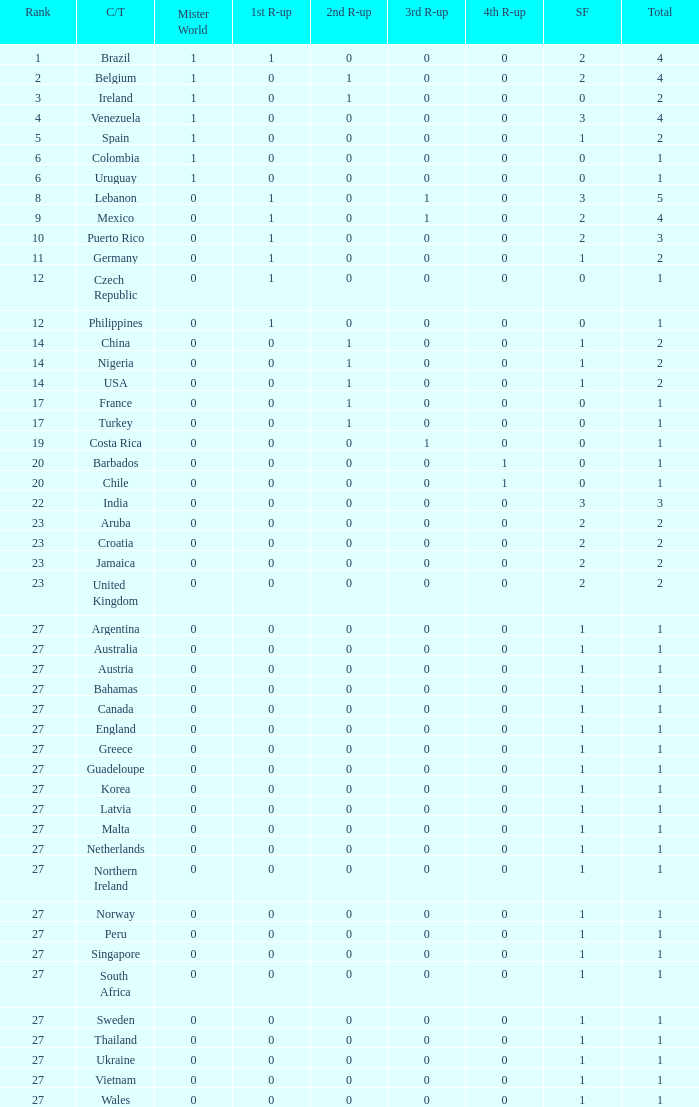What is the smallest 1st runner up value? 0.0. 